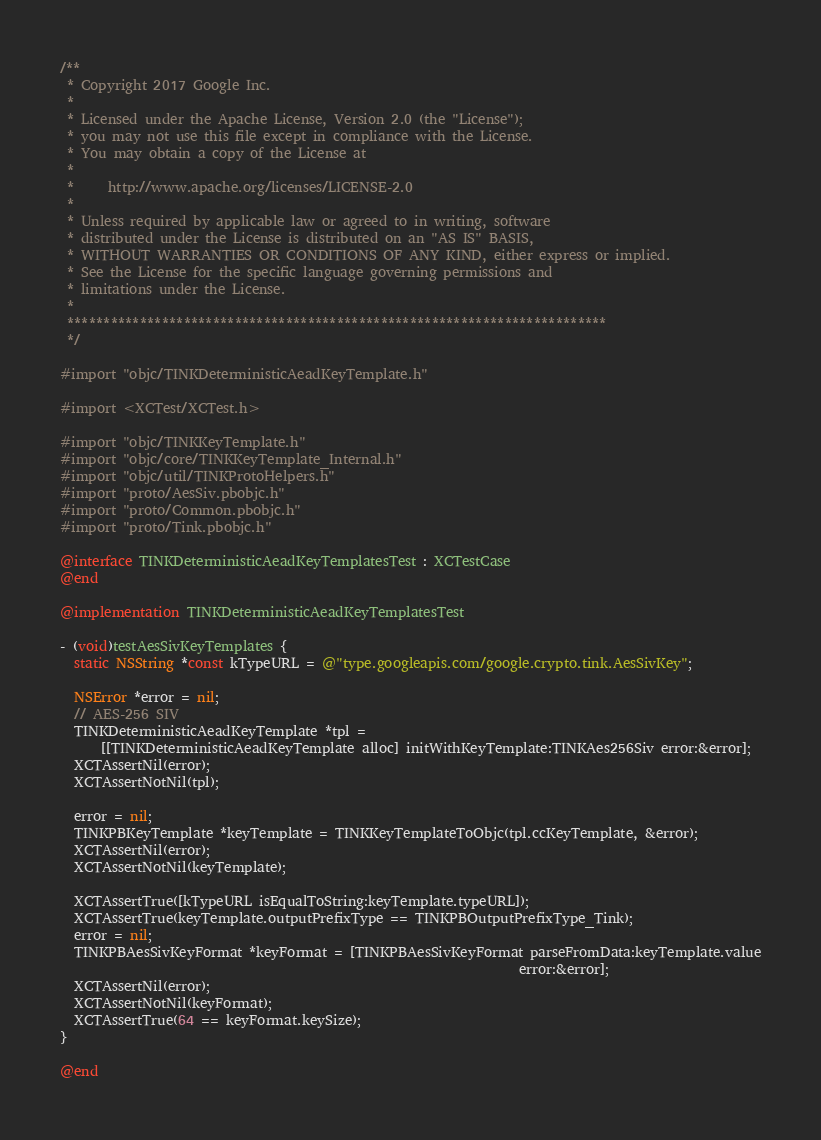Convert code to text. <code><loc_0><loc_0><loc_500><loc_500><_ObjectiveC_>/**
 * Copyright 2017 Google Inc.
 *
 * Licensed under the Apache License, Version 2.0 (the "License");
 * you may not use this file except in compliance with the License.
 * You may obtain a copy of the License at
 *
 *     http://www.apache.org/licenses/LICENSE-2.0
 *
 * Unless required by applicable law or agreed to in writing, software
 * distributed under the License is distributed on an "AS IS" BASIS,
 * WITHOUT WARRANTIES OR CONDITIONS OF ANY KIND, either express or implied.
 * See the License for the specific language governing permissions and
 * limitations under the License.
 *
 **************************************************************************
 */

#import "objc/TINKDeterministicAeadKeyTemplate.h"

#import <XCTest/XCTest.h>

#import "objc/TINKKeyTemplate.h"
#import "objc/core/TINKKeyTemplate_Internal.h"
#import "objc/util/TINKProtoHelpers.h"
#import "proto/AesSiv.pbobjc.h"
#import "proto/Common.pbobjc.h"
#import "proto/Tink.pbobjc.h"

@interface TINKDeterministicAeadKeyTemplatesTest : XCTestCase
@end

@implementation TINKDeterministicAeadKeyTemplatesTest

- (void)testAesSivKeyTemplates {
  static NSString *const kTypeURL = @"type.googleapis.com/google.crypto.tink.AesSivKey";

  NSError *error = nil;
  // AES-256 SIV
  TINKDeterministicAeadKeyTemplate *tpl =
      [[TINKDeterministicAeadKeyTemplate alloc] initWithKeyTemplate:TINKAes256Siv error:&error];
  XCTAssertNil(error);
  XCTAssertNotNil(tpl);

  error = nil;
  TINKPBKeyTemplate *keyTemplate = TINKKeyTemplateToObjc(tpl.ccKeyTemplate, &error);
  XCTAssertNil(error);
  XCTAssertNotNil(keyTemplate);

  XCTAssertTrue([kTypeURL isEqualToString:keyTemplate.typeURL]);
  XCTAssertTrue(keyTemplate.outputPrefixType == TINKPBOutputPrefixType_Tink);
  error = nil;
  TINKPBAesSivKeyFormat *keyFormat = [TINKPBAesSivKeyFormat parseFromData:keyTemplate.value
                                                                    error:&error];
  XCTAssertNil(error);
  XCTAssertNotNil(keyFormat);
  XCTAssertTrue(64 == keyFormat.keySize);
}

@end
</code> 